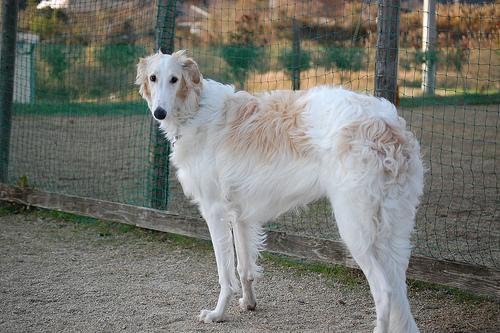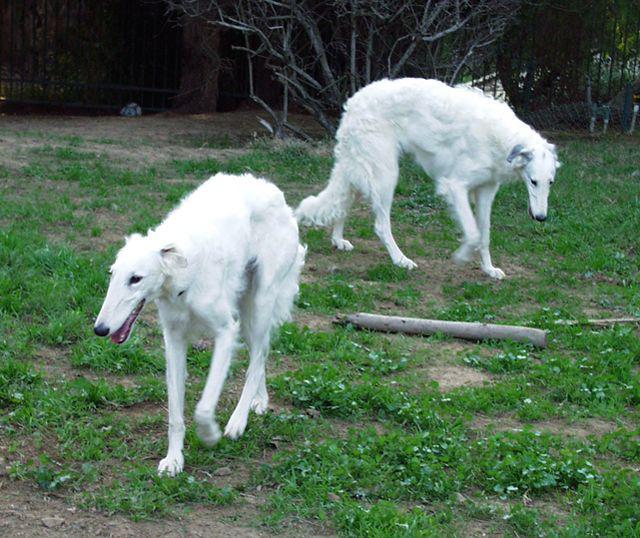The first image is the image on the left, the second image is the image on the right. Examine the images to the left and right. Is the description "In both images the dog is turned toward the right side of the image." accurate? Answer yes or no. No. 